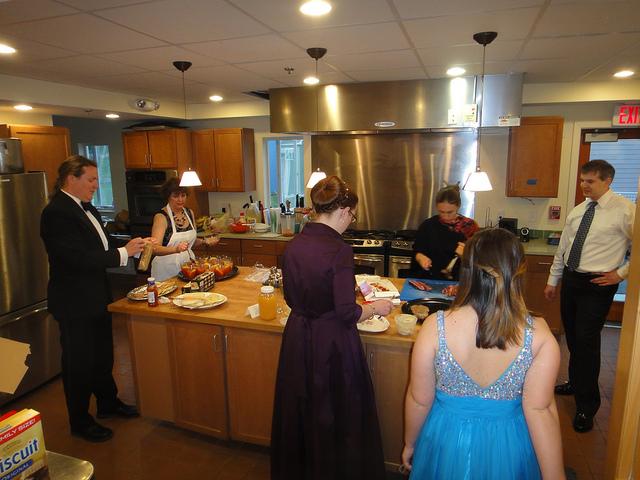Which meal of the day are they having?
Answer briefly. Dinner. What are they celebrating?
Give a very brief answer. Wedding. How many squares are there on the ceiling?
Keep it brief. 24. Are the people having a party?
Write a very short answer. Yes. Where is the girl with brown hair pulled back?
Keep it brief. At counter. 